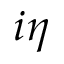<formula> <loc_0><loc_0><loc_500><loc_500>i \eta</formula> 